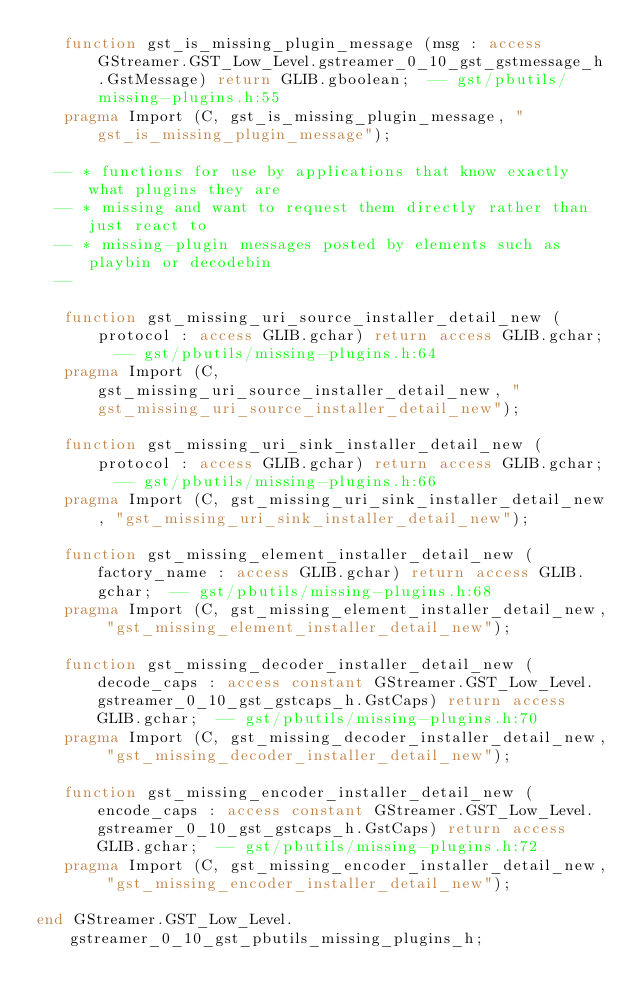Convert code to text. <code><loc_0><loc_0><loc_500><loc_500><_Ada_>   function gst_is_missing_plugin_message (msg : access GStreamer.GST_Low_Level.gstreamer_0_10_gst_gstmessage_h.GstMessage) return GLIB.gboolean;  -- gst/pbutils/missing-plugins.h:55
   pragma Import (C, gst_is_missing_plugin_message, "gst_is_missing_plugin_message");

  -- * functions for use by applications that know exactly what plugins they are
  -- * missing and want to request them directly rather than just react to
  -- * missing-plugin messages posted by elements such as playbin or decodebin
  --  

   function gst_missing_uri_source_installer_detail_new (protocol : access GLIB.gchar) return access GLIB.gchar;  -- gst/pbutils/missing-plugins.h:64
   pragma Import (C, gst_missing_uri_source_installer_detail_new, "gst_missing_uri_source_installer_detail_new");

   function gst_missing_uri_sink_installer_detail_new (protocol : access GLIB.gchar) return access GLIB.gchar;  -- gst/pbutils/missing-plugins.h:66
   pragma Import (C, gst_missing_uri_sink_installer_detail_new, "gst_missing_uri_sink_installer_detail_new");

   function gst_missing_element_installer_detail_new (factory_name : access GLIB.gchar) return access GLIB.gchar;  -- gst/pbutils/missing-plugins.h:68
   pragma Import (C, gst_missing_element_installer_detail_new, "gst_missing_element_installer_detail_new");

   function gst_missing_decoder_installer_detail_new (decode_caps : access constant GStreamer.GST_Low_Level.gstreamer_0_10_gst_gstcaps_h.GstCaps) return access GLIB.gchar;  -- gst/pbutils/missing-plugins.h:70
   pragma Import (C, gst_missing_decoder_installer_detail_new, "gst_missing_decoder_installer_detail_new");

   function gst_missing_encoder_installer_detail_new (encode_caps : access constant GStreamer.GST_Low_Level.gstreamer_0_10_gst_gstcaps_h.GstCaps) return access GLIB.gchar;  -- gst/pbutils/missing-plugins.h:72
   pragma Import (C, gst_missing_encoder_installer_detail_new, "gst_missing_encoder_installer_detail_new");

end GStreamer.GST_Low_Level.gstreamer_0_10_gst_pbutils_missing_plugins_h;
</code> 